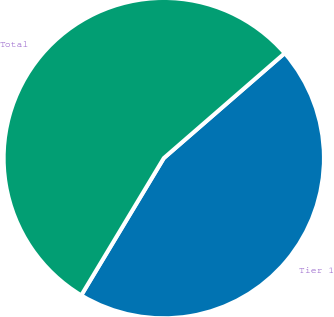<chart> <loc_0><loc_0><loc_500><loc_500><pie_chart><fcel>Tier 1<fcel>Total<nl><fcel>45.0%<fcel>55.0%<nl></chart> 